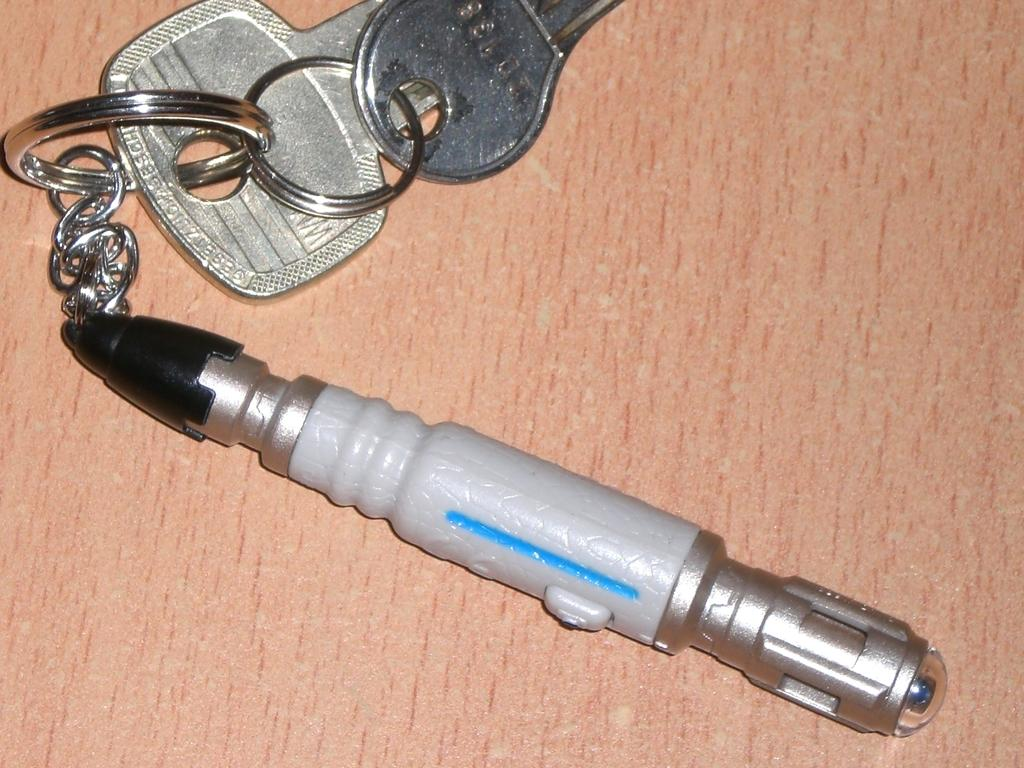What objects are present in the image? There are keys and a keychain in the image. How are the keys attached to the keychain? The keys and keychain appear to resemble a laser light. Can you describe the design of the keychain? The keychain resembles a laser light, which is a unique and eye-catching design. What message does the person in the image say as they wave good-bye? There is no person in the image, and no one is waving good-bye. 